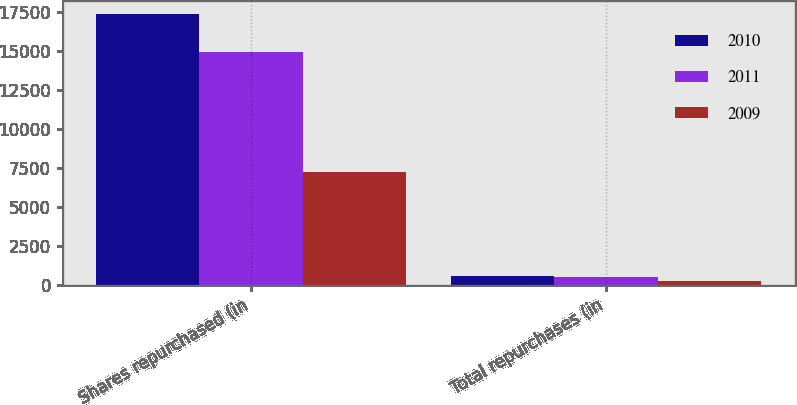Convert chart to OTSL. <chart><loc_0><loc_0><loc_500><loc_500><stacked_bar_chart><ecel><fcel>Shares repurchased (in<fcel>Total repurchases (in<nl><fcel>2010<fcel>17338<fcel>575<nl><fcel>2011<fcel>14920<fcel>501<nl><fcel>2009<fcel>7237<fcel>226<nl></chart> 